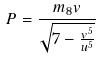Convert formula to latex. <formula><loc_0><loc_0><loc_500><loc_500>P = \frac { m _ { 8 } v } { \sqrt { 7 - \frac { v ^ { 5 } } { u ^ { 5 } } } }</formula> 